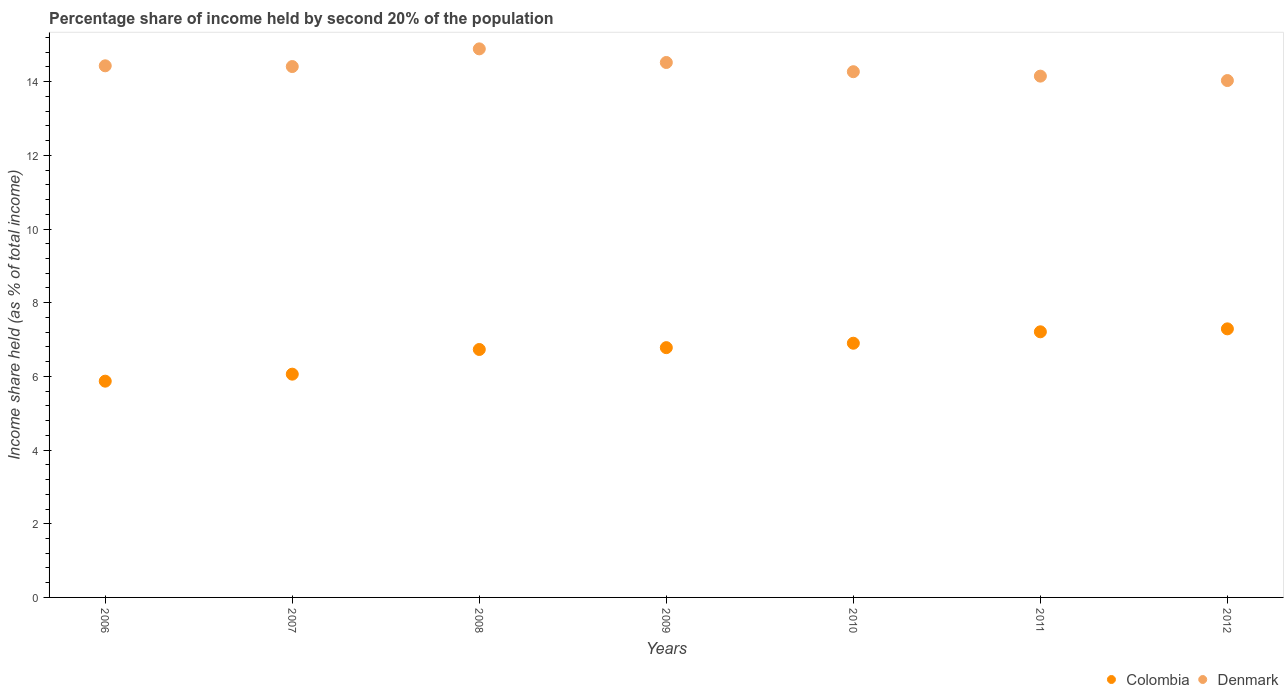Is the number of dotlines equal to the number of legend labels?
Ensure brevity in your answer.  Yes. What is the share of income held by second 20% of the population in Colombia in 2012?
Make the answer very short. 7.29. Across all years, what is the maximum share of income held by second 20% of the population in Denmark?
Give a very brief answer. 14.89. Across all years, what is the minimum share of income held by second 20% of the population in Denmark?
Give a very brief answer. 14.03. In which year was the share of income held by second 20% of the population in Denmark minimum?
Give a very brief answer. 2012. What is the total share of income held by second 20% of the population in Denmark in the graph?
Keep it short and to the point. 100.7. What is the difference between the share of income held by second 20% of the population in Denmark in 2007 and that in 2010?
Ensure brevity in your answer.  0.14. What is the difference between the share of income held by second 20% of the population in Colombia in 2006 and the share of income held by second 20% of the population in Denmark in 2009?
Offer a terse response. -8.65. What is the average share of income held by second 20% of the population in Denmark per year?
Your response must be concise. 14.39. In the year 2008, what is the difference between the share of income held by second 20% of the population in Colombia and share of income held by second 20% of the population in Denmark?
Give a very brief answer. -8.16. In how many years, is the share of income held by second 20% of the population in Colombia greater than 7.2 %?
Your answer should be compact. 2. What is the ratio of the share of income held by second 20% of the population in Colombia in 2009 to that in 2010?
Provide a succinct answer. 0.98. What is the difference between the highest and the second highest share of income held by second 20% of the population in Denmark?
Offer a very short reply. 0.37. What is the difference between the highest and the lowest share of income held by second 20% of the population in Colombia?
Your answer should be very brief. 1.42. In how many years, is the share of income held by second 20% of the population in Colombia greater than the average share of income held by second 20% of the population in Colombia taken over all years?
Your response must be concise. 5. Is the sum of the share of income held by second 20% of the population in Colombia in 2007 and 2012 greater than the maximum share of income held by second 20% of the population in Denmark across all years?
Provide a short and direct response. No. Does the share of income held by second 20% of the population in Colombia monotonically increase over the years?
Your response must be concise. Yes. Is the share of income held by second 20% of the population in Colombia strictly greater than the share of income held by second 20% of the population in Denmark over the years?
Offer a terse response. No. Is the share of income held by second 20% of the population in Colombia strictly less than the share of income held by second 20% of the population in Denmark over the years?
Offer a very short reply. Yes. How many dotlines are there?
Give a very brief answer. 2. How many years are there in the graph?
Make the answer very short. 7. What is the difference between two consecutive major ticks on the Y-axis?
Give a very brief answer. 2. Does the graph contain any zero values?
Keep it short and to the point. No. Does the graph contain grids?
Offer a terse response. No. Where does the legend appear in the graph?
Keep it short and to the point. Bottom right. How many legend labels are there?
Your answer should be compact. 2. How are the legend labels stacked?
Ensure brevity in your answer.  Horizontal. What is the title of the graph?
Your answer should be very brief. Percentage share of income held by second 20% of the population. Does "Mauritius" appear as one of the legend labels in the graph?
Provide a short and direct response. No. What is the label or title of the Y-axis?
Your response must be concise. Income share held (as % of total income). What is the Income share held (as % of total income) of Colombia in 2006?
Ensure brevity in your answer.  5.87. What is the Income share held (as % of total income) in Denmark in 2006?
Make the answer very short. 14.43. What is the Income share held (as % of total income) of Colombia in 2007?
Ensure brevity in your answer.  6.06. What is the Income share held (as % of total income) in Denmark in 2007?
Offer a very short reply. 14.41. What is the Income share held (as % of total income) in Colombia in 2008?
Give a very brief answer. 6.73. What is the Income share held (as % of total income) of Denmark in 2008?
Offer a very short reply. 14.89. What is the Income share held (as % of total income) in Colombia in 2009?
Offer a very short reply. 6.78. What is the Income share held (as % of total income) of Denmark in 2009?
Your answer should be very brief. 14.52. What is the Income share held (as % of total income) in Colombia in 2010?
Give a very brief answer. 6.9. What is the Income share held (as % of total income) in Denmark in 2010?
Make the answer very short. 14.27. What is the Income share held (as % of total income) in Colombia in 2011?
Offer a very short reply. 7.21. What is the Income share held (as % of total income) of Denmark in 2011?
Keep it short and to the point. 14.15. What is the Income share held (as % of total income) in Colombia in 2012?
Your answer should be very brief. 7.29. What is the Income share held (as % of total income) in Denmark in 2012?
Your answer should be very brief. 14.03. Across all years, what is the maximum Income share held (as % of total income) in Colombia?
Make the answer very short. 7.29. Across all years, what is the maximum Income share held (as % of total income) of Denmark?
Your answer should be compact. 14.89. Across all years, what is the minimum Income share held (as % of total income) in Colombia?
Keep it short and to the point. 5.87. Across all years, what is the minimum Income share held (as % of total income) of Denmark?
Your answer should be compact. 14.03. What is the total Income share held (as % of total income) of Colombia in the graph?
Your answer should be compact. 46.84. What is the total Income share held (as % of total income) of Denmark in the graph?
Provide a succinct answer. 100.7. What is the difference between the Income share held (as % of total income) of Colombia in 2006 and that in 2007?
Your answer should be compact. -0.19. What is the difference between the Income share held (as % of total income) in Colombia in 2006 and that in 2008?
Your answer should be compact. -0.86. What is the difference between the Income share held (as % of total income) in Denmark in 2006 and that in 2008?
Your answer should be very brief. -0.46. What is the difference between the Income share held (as % of total income) in Colombia in 2006 and that in 2009?
Keep it short and to the point. -0.91. What is the difference between the Income share held (as % of total income) of Denmark in 2006 and that in 2009?
Ensure brevity in your answer.  -0.09. What is the difference between the Income share held (as % of total income) of Colombia in 2006 and that in 2010?
Offer a very short reply. -1.03. What is the difference between the Income share held (as % of total income) in Denmark in 2006 and that in 2010?
Provide a succinct answer. 0.16. What is the difference between the Income share held (as % of total income) in Colombia in 2006 and that in 2011?
Make the answer very short. -1.34. What is the difference between the Income share held (as % of total income) of Denmark in 2006 and that in 2011?
Provide a short and direct response. 0.28. What is the difference between the Income share held (as % of total income) of Colombia in 2006 and that in 2012?
Make the answer very short. -1.42. What is the difference between the Income share held (as % of total income) in Denmark in 2006 and that in 2012?
Offer a very short reply. 0.4. What is the difference between the Income share held (as % of total income) of Colombia in 2007 and that in 2008?
Your response must be concise. -0.67. What is the difference between the Income share held (as % of total income) in Denmark in 2007 and that in 2008?
Your response must be concise. -0.48. What is the difference between the Income share held (as % of total income) of Colombia in 2007 and that in 2009?
Your answer should be compact. -0.72. What is the difference between the Income share held (as % of total income) in Denmark in 2007 and that in 2009?
Offer a very short reply. -0.11. What is the difference between the Income share held (as % of total income) of Colombia in 2007 and that in 2010?
Offer a terse response. -0.84. What is the difference between the Income share held (as % of total income) of Denmark in 2007 and that in 2010?
Make the answer very short. 0.14. What is the difference between the Income share held (as % of total income) of Colombia in 2007 and that in 2011?
Ensure brevity in your answer.  -1.15. What is the difference between the Income share held (as % of total income) of Denmark in 2007 and that in 2011?
Make the answer very short. 0.26. What is the difference between the Income share held (as % of total income) of Colombia in 2007 and that in 2012?
Offer a terse response. -1.23. What is the difference between the Income share held (as % of total income) of Denmark in 2007 and that in 2012?
Your answer should be very brief. 0.38. What is the difference between the Income share held (as % of total income) of Colombia in 2008 and that in 2009?
Make the answer very short. -0.05. What is the difference between the Income share held (as % of total income) of Denmark in 2008 and that in 2009?
Your response must be concise. 0.37. What is the difference between the Income share held (as % of total income) of Colombia in 2008 and that in 2010?
Your answer should be compact. -0.17. What is the difference between the Income share held (as % of total income) of Denmark in 2008 and that in 2010?
Ensure brevity in your answer.  0.62. What is the difference between the Income share held (as % of total income) in Colombia in 2008 and that in 2011?
Your answer should be compact. -0.48. What is the difference between the Income share held (as % of total income) of Denmark in 2008 and that in 2011?
Provide a succinct answer. 0.74. What is the difference between the Income share held (as % of total income) of Colombia in 2008 and that in 2012?
Provide a short and direct response. -0.56. What is the difference between the Income share held (as % of total income) of Denmark in 2008 and that in 2012?
Offer a very short reply. 0.86. What is the difference between the Income share held (as % of total income) in Colombia in 2009 and that in 2010?
Provide a short and direct response. -0.12. What is the difference between the Income share held (as % of total income) of Denmark in 2009 and that in 2010?
Give a very brief answer. 0.25. What is the difference between the Income share held (as % of total income) in Colombia in 2009 and that in 2011?
Your answer should be very brief. -0.43. What is the difference between the Income share held (as % of total income) in Denmark in 2009 and that in 2011?
Provide a succinct answer. 0.37. What is the difference between the Income share held (as % of total income) in Colombia in 2009 and that in 2012?
Your answer should be compact. -0.51. What is the difference between the Income share held (as % of total income) of Denmark in 2009 and that in 2012?
Provide a short and direct response. 0.49. What is the difference between the Income share held (as % of total income) of Colombia in 2010 and that in 2011?
Keep it short and to the point. -0.31. What is the difference between the Income share held (as % of total income) of Denmark in 2010 and that in 2011?
Your answer should be compact. 0.12. What is the difference between the Income share held (as % of total income) in Colombia in 2010 and that in 2012?
Your answer should be compact. -0.39. What is the difference between the Income share held (as % of total income) in Denmark in 2010 and that in 2012?
Your answer should be compact. 0.24. What is the difference between the Income share held (as % of total income) in Colombia in 2011 and that in 2012?
Your answer should be compact. -0.08. What is the difference between the Income share held (as % of total income) in Denmark in 2011 and that in 2012?
Keep it short and to the point. 0.12. What is the difference between the Income share held (as % of total income) in Colombia in 2006 and the Income share held (as % of total income) in Denmark in 2007?
Give a very brief answer. -8.54. What is the difference between the Income share held (as % of total income) in Colombia in 2006 and the Income share held (as % of total income) in Denmark in 2008?
Your response must be concise. -9.02. What is the difference between the Income share held (as % of total income) in Colombia in 2006 and the Income share held (as % of total income) in Denmark in 2009?
Provide a succinct answer. -8.65. What is the difference between the Income share held (as % of total income) in Colombia in 2006 and the Income share held (as % of total income) in Denmark in 2011?
Your answer should be compact. -8.28. What is the difference between the Income share held (as % of total income) of Colombia in 2006 and the Income share held (as % of total income) of Denmark in 2012?
Give a very brief answer. -8.16. What is the difference between the Income share held (as % of total income) in Colombia in 2007 and the Income share held (as % of total income) in Denmark in 2008?
Provide a short and direct response. -8.83. What is the difference between the Income share held (as % of total income) of Colombia in 2007 and the Income share held (as % of total income) of Denmark in 2009?
Your answer should be compact. -8.46. What is the difference between the Income share held (as % of total income) in Colombia in 2007 and the Income share held (as % of total income) in Denmark in 2010?
Provide a succinct answer. -8.21. What is the difference between the Income share held (as % of total income) of Colombia in 2007 and the Income share held (as % of total income) of Denmark in 2011?
Make the answer very short. -8.09. What is the difference between the Income share held (as % of total income) of Colombia in 2007 and the Income share held (as % of total income) of Denmark in 2012?
Offer a terse response. -7.97. What is the difference between the Income share held (as % of total income) in Colombia in 2008 and the Income share held (as % of total income) in Denmark in 2009?
Your response must be concise. -7.79. What is the difference between the Income share held (as % of total income) of Colombia in 2008 and the Income share held (as % of total income) of Denmark in 2010?
Provide a short and direct response. -7.54. What is the difference between the Income share held (as % of total income) of Colombia in 2008 and the Income share held (as % of total income) of Denmark in 2011?
Keep it short and to the point. -7.42. What is the difference between the Income share held (as % of total income) of Colombia in 2009 and the Income share held (as % of total income) of Denmark in 2010?
Keep it short and to the point. -7.49. What is the difference between the Income share held (as % of total income) of Colombia in 2009 and the Income share held (as % of total income) of Denmark in 2011?
Offer a terse response. -7.37. What is the difference between the Income share held (as % of total income) of Colombia in 2009 and the Income share held (as % of total income) of Denmark in 2012?
Keep it short and to the point. -7.25. What is the difference between the Income share held (as % of total income) in Colombia in 2010 and the Income share held (as % of total income) in Denmark in 2011?
Offer a very short reply. -7.25. What is the difference between the Income share held (as % of total income) of Colombia in 2010 and the Income share held (as % of total income) of Denmark in 2012?
Your answer should be very brief. -7.13. What is the difference between the Income share held (as % of total income) of Colombia in 2011 and the Income share held (as % of total income) of Denmark in 2012?
Make the answer very short. -6.82. What is the average Income share held (as % of total income) in Colombia per year?
Make the answer very short. 6.69. What is the average Income share held (as % of total income) of Denmark per year?
Ensure brevity in your answer.  14.39. In the year 2006, what is the difference between the Income share held (as % of total income) in Colombia and Income share held (as % of total income) in Denmark?
Provide a succinct answer. -8.56. In the year 2007, what is the difference between the Income share held (as % of total income) in Colombia and Income share held (as % of total income) in Denmark?
Keep it short and to the point. -8.35. In the year 2008, what is the difference between the Income share held (as % of total income) of Colombia and Income share held (as % of total income) of Denmark?
Offer a very short reply. -8.16. In the year 2009, what is the difference between the Income share held (as % of total income) of Colombia and Income share held (as % of total income) of Denmark?
Your response must be concise. -7.74. In the year 2010, what is the difference between the Income share held (as % of total income) in Colombia and Income share held (as % of total income) in Denmark?
Offer a terse response. -7.37. In the year 2011, what is the difference between the Income share held (as % of total income) in Colombia and Income share held (as % of total income) in Denmark?
Offer a terse response. -6.94. In the year 2012, what is the difference between the Income share held (as % of total income) of Colombia and Income share held (as % of total income) of Denmark?
Offer a terse response. -6.74. What is the ratio of the Income share held (as % of total income) in Colombia in 2006 to that in 2007?
Make the answer very short. 0.97. What is the ratio of the Income share held (as % of total income) in Colombia in 2006 to that in 2008?
Give a very brief answer. 0.87. What is the ratio of the Income share held (as % of total income) of Denmark in 2006 to that in 2008?
Provide a succinct answer. 0.97. What is the ratio of the Income share held (as % of total income) in Colombia in 2006 to that in 2009?
Your answer should be compact. 0.87. What is the ratio of the Income share held (as % of total income) in Denmark in 2006 to that in 2009?
Keep it short and to the point. 0.99. What is the ratio of the Income share held (as % of total income) in Colombia in 2006 to that in 2010?
Provide a succinct answer. 0.85. What is the ratio of the Income share held (as % of total income) in Denmark in 2006 to that in 2010?
Your response must be concise. 1.01. What is the ratio of the Income share held (as % of total income) in Colombia in 2006 to that in 2011?
Ensure brevity in your answer.  0.81. What is the ratio of the Income share held (as % of total income) of Denmark in 2006 to that in 2011?
Make the answer very short. 1.02. What is the ratio of the Income share held (as % of total income) in Colombia in 2006 to that in 2012?
Your answer should be compact. 0.81. What is the ratio of the Income share held (as % of total income) of Denmark in 2006 to that in 2012?
Offer a terse response. 1.03. What is the ratio of the Income share held (as % of total income) of Colombia in 2007 to that in 2008?
Your answer should be compact. 0.9. What is the ratio of the Income share held (as % of total income) of Denmark in 2007 to that in 2008?
Ensure brevity in your answer.  0.97. What is the ratio of the Income share held (as % of total income) in Colombia in 2007 to that in 2009?
Provide a short and direct response. 0.89. What is the ratio of the Income share held (as % of total income) of Colombia in 2007 to that in 2010?
Provide a succinct answer. 0.88. What is the ratio of the Income share held (as % of total income) of Denmark in 2007 to that in 2010?
Keep it short and to the point. 1.01. What is the ratio of the Income share held (as % of total income) in Colombia in 2007 to that in 2011?
Ensure brevity in your answer.  0.84. What is the ratio of the Income share held (as % of total income) of Denmark in 2007 to that in 2011?
Provide a short and direct response. 1.02. What is the ratio of the Income share held (as % of total income) of Colombia in 2007 to that in 2012?
Offer a terse response. 0.83. What is the ratio of the Income share held (as % of total income) in Denmark in 2007 to that in 2012?
Make the answer very short. 1.03. What is the ratio of the Income share held (as % of total income) of Denmark in 2008 to that in 2009?
Offer a very short reply. 1.03. What is the ratio of the Income share held (as % of total income) in Colombia in 2008 to that in 2010?
Ensure brevity in your answer.  0.98. What is the ratio of the Income share held (as % of total income) in Denmark in 2008 to that in 2010?
Make the answer very short. 1.04. What is the ratio of the Income share held (as % of total income) in Colombia in 2008 to that in 2011?
Provide a short and direct response. 0.93. What is the ratio of the Income share held (as % of total income) of Denmark in 2008 to that in 2011?
Your response must be concise. 1.05. What is the ratio of the Income share held (as % of total income) of Colombia in 2008 to that in 2012?
Keep it short and to the point. 0.92. What is the ratio of the Income share held (as % of total income) of Denmark in 2008 to that in 2012?
Ensure brevity in your answer.  1.06. What is the ratio of the Income share held (as % of total income) in Colombia in 2009 to that in 2010?
Offer a very short reply. 0.98. What is the ratio of the Income share held (as % of total income) of Denmark in 2009 to that in 2010?
Give a very brief answer. 1.02. What is the ratio of the Income share held (as % of total income) of Colombia in 2009 to that in 2011?
Provide a short and direct response. 0.94. What is the ratio of the Income share held (as % of total income) of Denmark in 2009 to that in 2011?
Provide a succinct answer. 1.03. What is the ratio of the Income share held (as % of total income) in Colombia in 2009 to that in 2012?
Keep it short and to the point. 0.93. What is the ratio of the Income share held (as % of total income) in Denmark in 2009 to that in 2012?
Ensure brevity in your answer.  1.03. What is the ratio of the Income share held (as % of total income) in Denmark in 2010 to that in 2011?
Make the answer very short. 1.01. What is the ratio of the Income share held (as % of total income) of Colombia in 2010 to that in 2012?
Offer a very short reply. 0.95. What is the ratio of the Income share held (as % of total income) of Denmark in 2010 to that in 2012?
Keep it short and to the point. 1.02. What is the ratio of the Income share held (as % of total income) in Colombia in 2011 to that in 2012?
Your response must be concise. 0.99. What is the ratio of the Income share held (as % of total income) of Denmark in 2011 to that in 2012?
Provide a short and direct response. 1.01. What is the difference between the highest and the second highest Income share held (as % of total income) of Colombia?
Make the answer very short. 0.08. What is the difference between the highest and the second highest Income share held (as % of total income) of Denmark?
Make the answer very short. 0.37. What is the difference between the highest and the lowest Income share held (as % of total income) in Colombia?
Keep it short and to the point. 1.42. What is the difference between the highest and the lowest Income share held (as % of total income) of Denmark?
Ensure brevity in your answer.  0.86. 